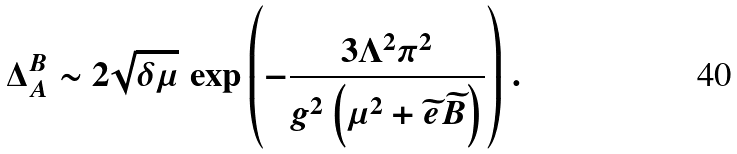Convert formula to latex. <formula><loc_0><loc_0><loc_500><loc_500>\Delta ^ { B } _ { A } \sim 2 \sqrt { \delta \mu } \, \exp { \left ( - \frac { 3 \Lambda ^ { 2 } \pi ^ { 2 } } { g ^ { 2 } \left ( \mu ^ { 2 } + \widetilde { e } \widetilde { B } \right ) } \right ) } \ .</formula> 